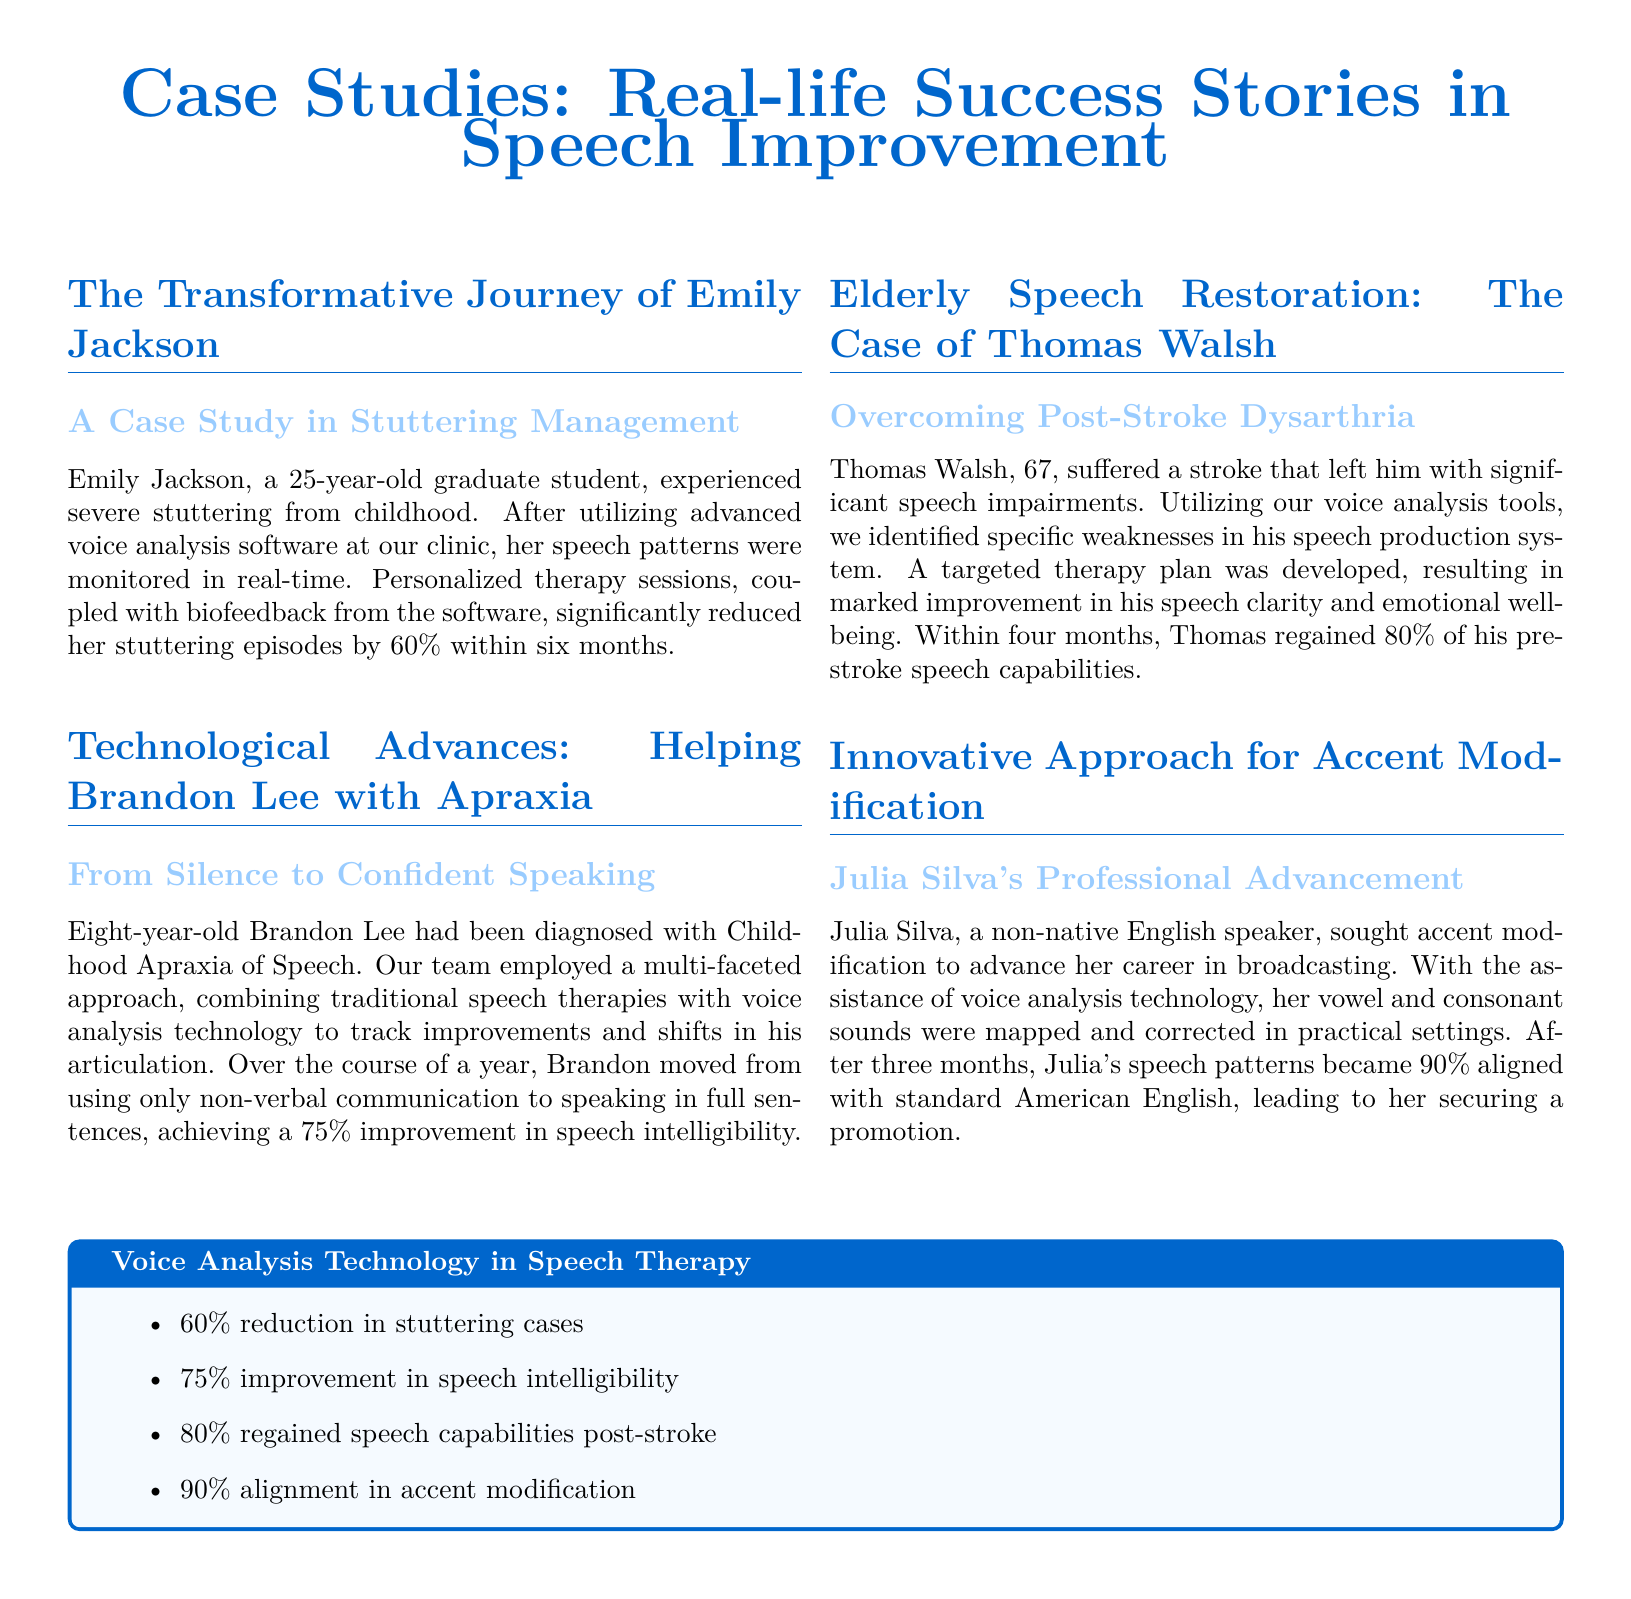What is the name of the first case study? The title of the first case study is "The Transformative Journey of Emily Jackson".
Answer: The Transformative Journey of Emily Jackson What condition did Brandon Lee have? Brandon Lee was diagnosed with Childhood Apraxia of Speech.
Answer: Childhood Apraxia of Speech What percentage did Thomas Walsh regain of his pre-stroke capabilities? Thomas Walsh regained 80% of his pre-stroke speech capabilities.
Answer: 80% How long did Julia Silva take to achieve significant improvement? Julia Silva achieved significant improvement in three months.
Answer: three months What was the improvement percentage in speech intelligibility for Brandon Lee? Brandon Lee achieved a 75% improvement in speech intelligibility.
Answer: 75% What percentage reduction in stuttering cases was reported? A 60% reduction in stuttering cases was reported.
Answer: 60% What type of technology is emphasized in the document? The document emphasizes voice analysis technology.
Answer: voice analysis technology What was the emotional condition of Thomas Walsh after therapy? Thomas Walsh showed marked improvement in his emotional well-being.
Answer: emotional well-being What is one of the key outcomes of using voice analysis technology? One key outcome is achieving a 90% alignment in accent modification.
Answer: 90% alignment in accent modification 